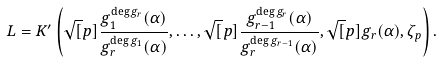<formula> <loc_0><loc_0><loc_500><loc_500>L = K ^ { \prime } \left ( \sqrt { [ } p ] { \frac { g _ { 1 } ^ { \deg g _ { r } } ( \alpha ) } { g _ { r } ^ { \deg g _ { 1 } } ( \alpha ) } } , \dots , \sqrt { [ } p ] { \frac { g _ { r - 1 } ^ { \deg g _ { r } } ( \alpha ) } { g _ { r } ^ { \deg g _ { r - 1 } } ( \alpha ) } } , \sqrt { [ } p ] { g _ { r } ( \alpha ) } , \zeta _ { p } \right ) .</formula> 